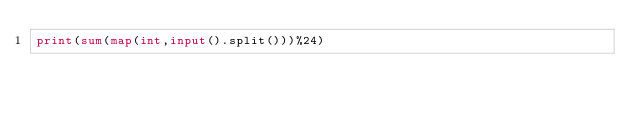Convert code to text. <code><loc_0><loc_0><loc_500><loc_500><_Python_>print(sum(map(int,input().split()))%24)</code> 